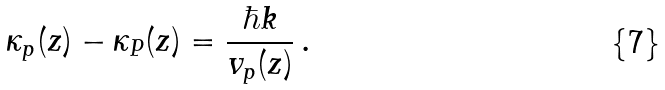Convert formula to latex. <formula><loc_0><loc_0><loc_500><loc_500>\kappa _ { p } ( z ) - \kappa _ { P } ( z ) = \frac { \hbar { k } } { v _ { p } ( z ) } \, .</formula> 